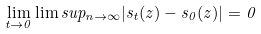Convert formula to latex. <formula><loc_0><loc_0><loc_500><loc_500>\lim _ { t \to 0 } \lim s u p _ { n \to \infty } | s _ { t } ( z ) - s _ { 0 } ( z ) | = 0</formula> 